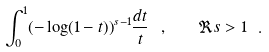Convert formula to latex. <formula><loc_0><loc_0><loc_500><loc_500>\int _ { 0 } ^ { 1 } ( - \log ( 1 - t ) ) ^ { s - 1 } \frac { d t } t \ , \quad \Re s > 1 \ .</formula> 